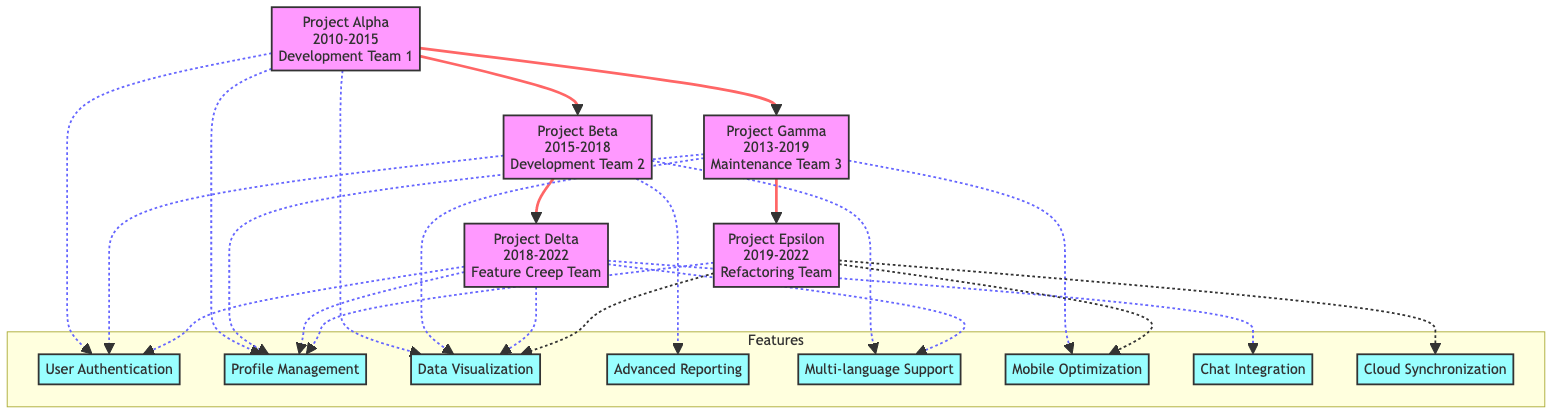What is the name of the project that started in 2010? By looking at the diagram, the project that has a start year of 2010 is "Project Alpha."
Answer: Project Alpha Which team developed Project Beta? The diagram clearly indicates that "Development Team 2" was assigned to Project Beta.
Answer: Development Team 2 How many features does Project Delta have? Counting the features listed under Project Delta from the diagram, there are five features: User Authentication, Profile Management, Data Visualization, Multi-language Support, and Chat Integration.
Answer: 5 Which project inherited features from Project Beta? The diagram shows that Project Delta has an arrow pointing from Project Beta, indicating that it inherited features from it.
Answer: Project Delta What features are unique to Project Gamma? In the diagram, Project Gamma has three features: Profile Management, Data Visualization, and Mobile Optimization, of which Mobile Optimization is not shared with Project Alpha or Project Beta.
Answer: Mobile Optimization What is the total number of projects represented in the diagram? The diagram displays a total of five different projects: Project Alpha, Project Beta, Project Gamma, Project Delta, and Project Epsilon.
Answer: 5 Which feature from Project Alpha is not included in Project Delta? The features of Project Delta include User Authentication, Profile Management, Data Visualization, Multi-language Support, and Chat Integration. Among these, Multi-language Support is the feature not included in Project Alpha.
Answer: Multi-language Support Does Project Epsilon inherit features from Project Beta? By reviewing the structure of the diagram, it's clear that Project Epsilon inherits features from Project Gamma, which in turn inherits from Project Alpha, not directly from Project Beta.
Answer: No Which team was responsible for Project Epsilon? According to the diagram, "Refactoring Team" managed Project Epsilon.
Answer: Refactoring Team 